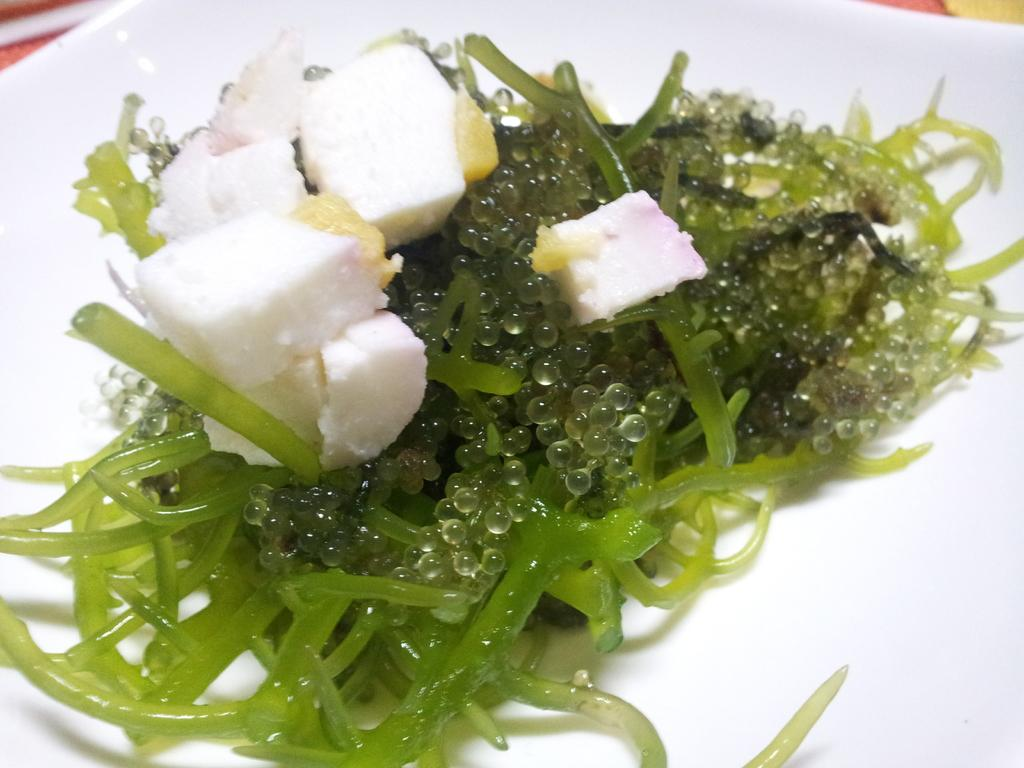What colors are the food items on the plate? There are green and white food items on the plate. What color is the plate? The plate is white. What type of bat can be seen flying over the plate in the image? There is no bat present in the image; it only features food items on a plate. 